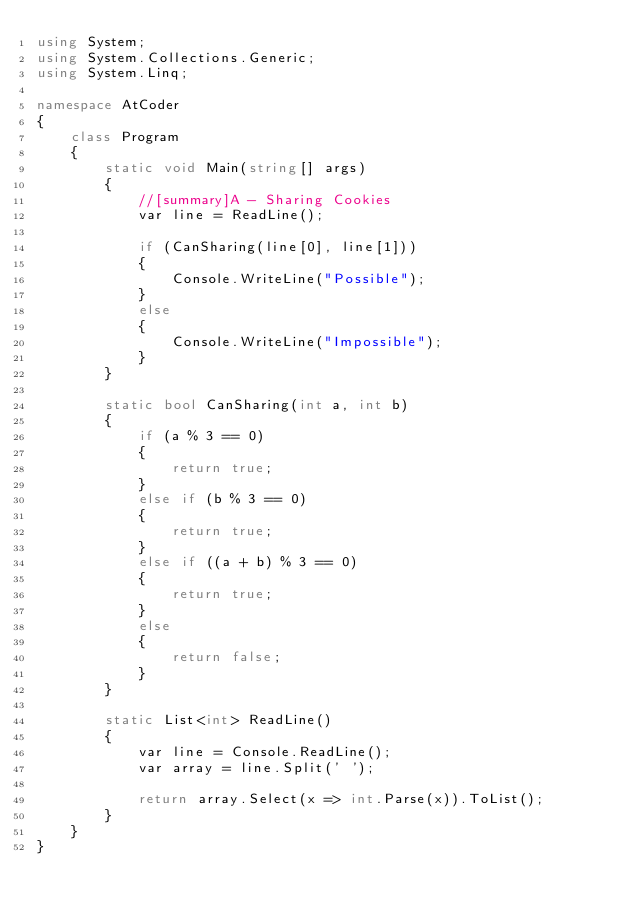<code> <loc_0><loc_0><loc_500><loc_500><_C#_>using System;
using System.Collections.Generic;
using System.Linq;

namespace AtCoder
{
    class Program
    {
        static void Main(string[] args)
        {
            //[summary]A - Sharing Cookies
            var line = ReadLine();

            if (CanSharing(line[0], line[1]))
            {
                Console.WriteLine("Possible");
            }
            else
            {
                Console.WriteLine("Impossible");
            }
        }

        static bool CanSharing(int a, int b)
        {
            if (a % 3 == 0)
            {
                return true;
            }
            else if (b % 3 == 0)
            {
                return true;
            }
            else if ((a + b) % 3 == 0)
            {
                return true;
            }
            else
            {
                return false;
            }
        }

        static List<int> ReadLine()
        {
            var line = Console.ReadLine();
            var array = line.Split(' ');

            return array.Select(x => int.Parse(x)).ToList();
        }
    }
}
</code> 